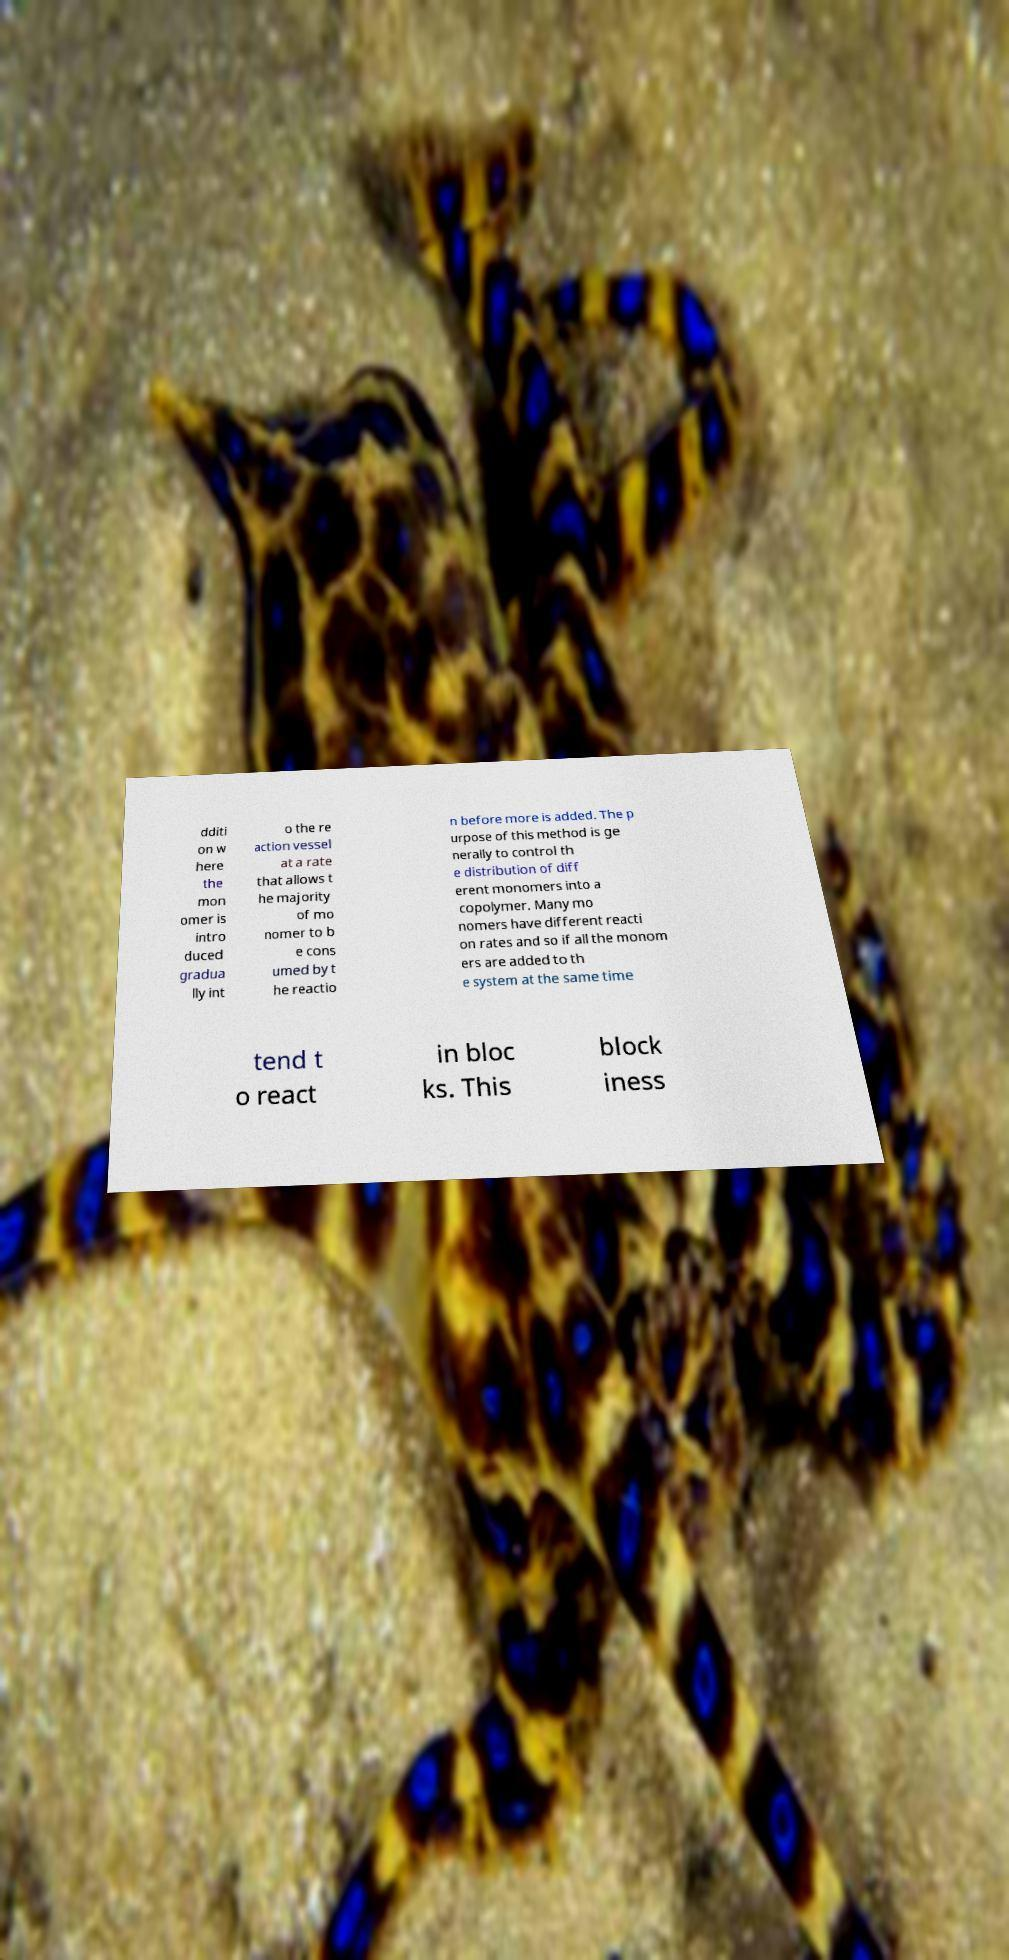What messages or text are displayed in this image? I need them in a readable, typed format. dditi on w here the mon omer is intro duced gradua lly int o the re action vessel at a rate that allows t he majority of mo nomer to b e cons umed by t he reactio n before more is added. The p urpose of this method is ge nerally to control th e distribution of diff erent monomers into a copolymer. Many mo nomers have different reacti on rates and so if all the monom ers are added to th e system at the same time tend t o react in bloc ks. This block iness 